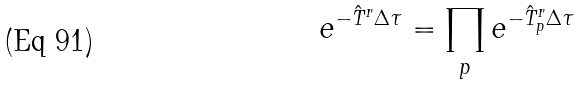<formula> <loc_0><loc_0><loc_500><loc_500>e ^ { - \hat { T } ^ { r } \Delta \tau } = \prod _ { p } e ^ { - \hat { T } ^ { r } _ { p } \Delta \tau }</formula> 